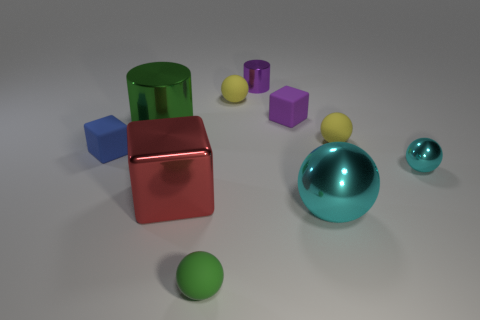Subtract 2 spheres. How many spheres are left? 3 Subtract all green spheres. How many spheres are left? 4 Subtract all large shiny balls. How many balls are left? 4 Subtract all brown spheres. Subtract all cyan blocks. How many spheres are left? 5 Subtract all cylinders. How many objects are left? 8 Add 7 small cyan balls. How many small cyan balls exist? 8 Subtract 0 cyan blocks. How many objects are left? 10 Subtract all tiny blue matte blocks. Subtract all small cyan metallic balls. How many objects are left? 8 Add 8 tiny green rubber spheres. How many tiny green rubber spheres are left? 9 